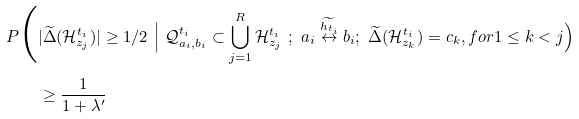Convert formula to latex. <formula><loc_0><loc_0><loc_500><loc_500>P \Big ( & | \widetilde { \Delta } ( \mathcal { H } ^ { t _ { i } } _ { z _ { j } } ) | \geq 1 / 2 \ \Big | \ \mathcal { Q } ^ { t _ { i } } _ { a _ { i } , b _ { i } } \subset \bigcup _ { j = 1 } ^ { R } \mathcal { H } _ { z _ { j } } ^ { t _ { i } } \ ; \ a _ { i } \overset { \widetilde { h _ { t _ { i } } } } { \leftrightarrow } b _ { i } ; \ \widetilde { \Delta } ( \mathcal { H } ^ { t _ { i } } _ { z _ { k } } ) = c _ { k } , f o r 1 \leq k < j \Big ) \\ & \geq \frac { 1 } { 1 + \lambda ^ { \prime } }</formula> 